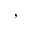Convert formula to latex. <formula><loc_0><loc_0><loc_500><loc_500>,</formula> 